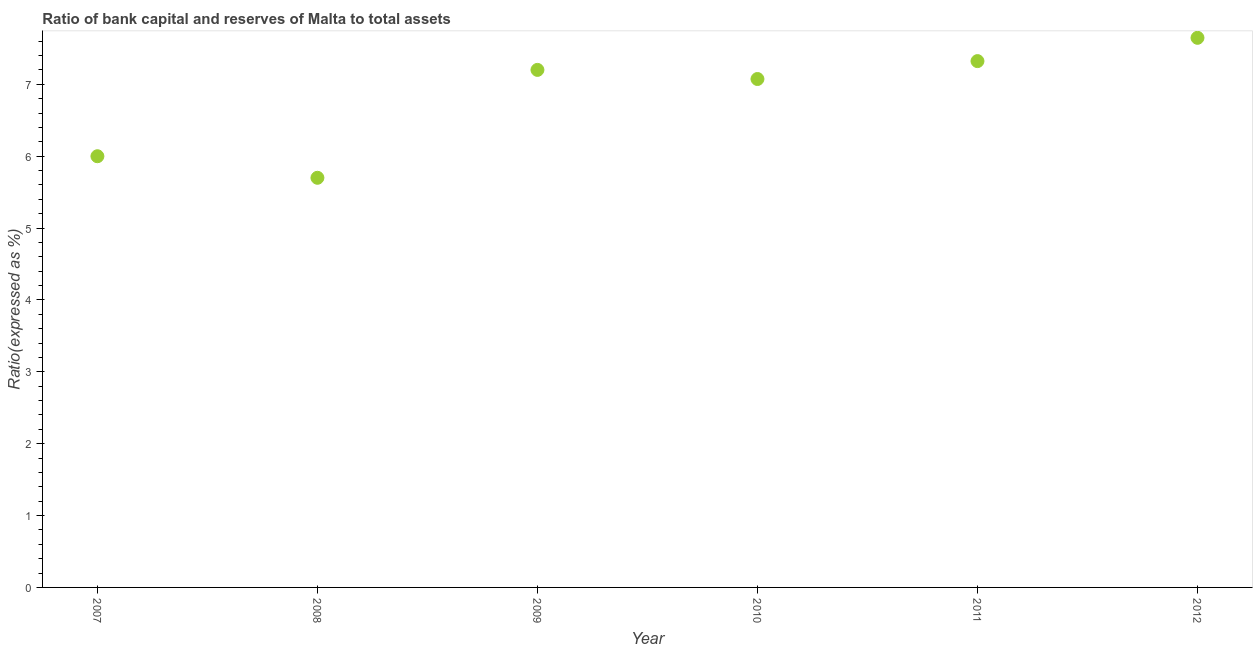What is the bank capital to assets ratio in 2012?
Your response must be concise. 7.65. Across all years, what is the maximum bank capital to assets ratio?
Give a very brief answer. 7.65. In which year was the bank capital to assets ratio maximum?
Provide a short and direct response. 2012. What is the sum of the bank capital to assets ratio?
Keep it short and to the point. 40.95. What is the difference between the bank capital to assets ratio in 2007 and 2009?
Offer a very short reply. -1.2. What is the average bank capital to assets ratio per year?
Your response must be concise. 6.82. What is the median bank capital to assets ratio?
Keep it short and to the point. 7.14. In how many years, is the bank capital to assets ratio greater than 4.6 %?
Your answer should be compact. 6. What is the ratio of the bank capital to assets ratio in 2010 to that in 2012?
Your answer should be very brief. 0.93. Is the difference between the bank capital to assets ratio in 2011 and 2012 greater than the difference between any two years?
Make the answer very short. No. What is the difference between the highest and the second highest bank capital to assets ratio?
Your response must be concise. 0.32. What is the difference between the highest and the lowest bank capital to assets ratio?
Your answer should be compact. 1.95. In how many years, is the bank capital to assets ratio greater than the average bank capital to assets ratio taken over all years?
Provide a short and direct response. 4. Does the bank capital to assets ratio monotonically increase over the years?
Provide a succinct answer. No. Are the values on the major ticks of Y-axis written in scientific E-notation?
Provide a short and direct response. No. What is the title of the graph?
Give a very brief answer. Ratio of bank capital and reserves of Malta to total assets. What is the label or title of the X-axis?
Make the answer very short. Year. What is the label or title of the Y-axis?
Your answer should be compact. Ratio(expressed as %). What is the Ratio(expressed as %) in 2009?
Your response must be concise. 7.2. What is the Ratio(expressed as %) in 2010?
Your answer should be very brief. 7.07. What is the Ratio(expressed as %) in 2011?
Your answer should be compact. 7.32. What is the Ratio(expressed as %) in 2012?
Your answer should be compact. 7.65. What is the difference between the Ratio(expressed as %) in 2007 and 2009?
Make the answer very short. -1.2. What is the difference between the Ratio(expressed as %) in 2007 and 2010?
Provide a succinct answer. -1.07. What is the difference between the Ratio(expressed as %) in 2007 and 2011?
Offer a very short reply. -1.32. What is the difference between the Ratio(expressed as %) in 2007 and 2012?
Ensure brevity in your answer.  -1.65. What is the difference between the Ratio(expressed as %) in 2008 and 2009?
Offer a very short reply. -1.5. What is the difference between the Ratio(expressed as %) in 2008 and 2010?
Your answer should be very brief. -1.37. What is the difference between the Ratio(expressed as %) in 2008 and 2011?
Keep it short and to the point. -1.62. What is the difference between the Ratio(expressed as %) in 2008 and 2012?
Your answer should be very brief. -1.95. What is the difference between the Ratio(expressed as %) in 2009 and 2010?
Offer a terse response. 0.13. What is the difference between the Ratio(expressed as %) in 2009 and 2011?
Ensure brevity in your answer.  -0.12. What is the difference between the Ratio(expressed as %) in 2009 and 2012?
Provide a succinct answer. -0.45. What is the difference between the Ratio(expressed as %) in 2010 and 2011?
Offer a terse response. -0.25. What is the difference between the Ratio(expressed as %) in 2010 and 2012?
Your answer should be compact. -0.57. What is the difference between the Ratio(expressed as %) in 2011 and 2012?
Offer a very short reply. -0.32. What is the ratio of the Ratio(expressed as %) in 2007 to that in 2008?
Provide a short and direct response. 1.05. What is the ratio of the Ratio(expressed as %) in 2007 to that in 2009?
Your answer should be very brief. 0.83. What is the ratio of the Ratio(expressed as %) in 2007 to that in 2010?
Keep it short and to the point. 0.85. What is the ratio of the Ratio(expressed as %) in 2007 to that in 2011?
Provide a succinct answer. 0.82. What is the ratio of the Ratio(expressed as %) in 2007 to that in 2012?
Make the answer very short. 0.79. What is the ratio of the Ratio(expressed as %) in 2008 to that in 2009?
Your answer should be very brief. 0.79. What is the ratio of the Ratio(expressed as %) in 2008 to that in 2010?
Ensure brevity in your answer.  0.81. What is the ratio of the Ratio(expressed as %) in 2008 to that in 2011?
Your answer should be very brief. 0.78. What is the ratio of the Ratio(expressed as %) in 2008 to that in 2012?
Your response must be concise. 0.74. What is the ratio of the Ratio(expressed as %) in 2009 to that in 2010?
Ensure brevity in your answer.  1.02. What is the ratio of the Ratio(expressed as %) in 2009 to that in 2011?
Provide a succinct answer. 0.98. What is the ratio of the Ratio(expressed as %) in 2009 to that in 2012?
Your answer should be very brief. 0.94. What is the ratio of the Ratio(expressed as %) in 2010 to that in 2012?
Your answer should be very brief. 0.93. What is the ratio of the Ratio(expressed as %) in 2011 to that in 2012?
Your response must be concise. 0.96. 